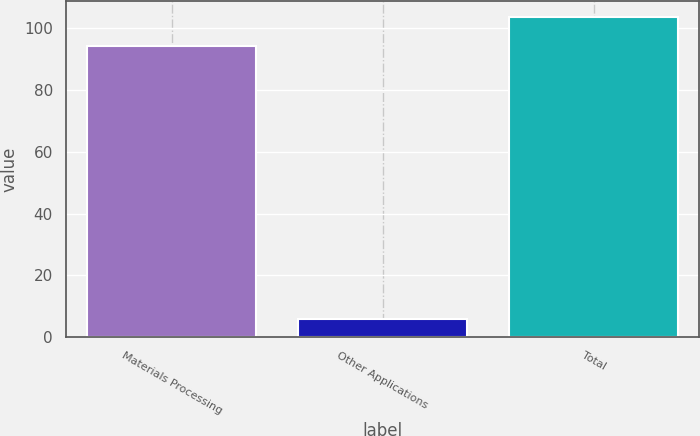Convert chart to OTSL. <chart><loc_0><loc_0><loc_500><loc_500><bar_chart><fcel>Materials Processing<fcel>Other Applications<fcel>Total<nl><fcel>94.2<fcel>5.8<fcel>103.62<nl></chart> 